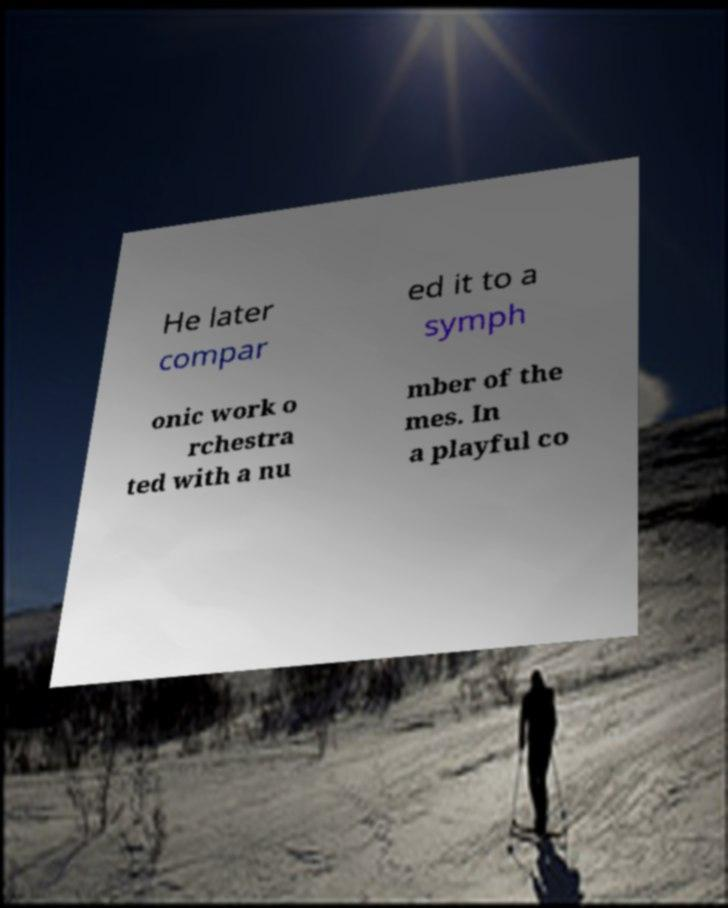There's text embedded in this image that I need extracted. Can you transcribe it verbatim? He later compar ed it to a symph onic work o rchestra ted with a nu mber of the mes. In a playful co 